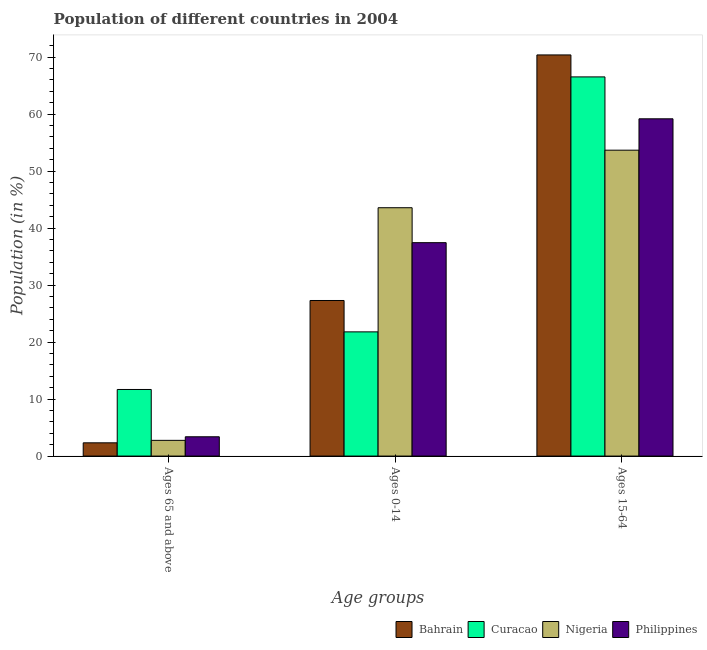How many different coloured bars are there?
Offer a very short reply. 4. How many groups of bars are there?
Provide a succinct answer. 3. How many bars are there on the 2nd tick from the left?
Offer a terse response. 4. How many bars are there on the 2nd tick from the right?
Offer a terse response. 4. What is the label of the 2nd group of bars from the left?
Offer a terse response. Ages 0-14. What is the percentage of population within the age-group 15-64 in Nigeria?
Provide a short and direct response. 53.67. Across all countries, what is the maximum percentage of population within the age-group 0-14?
Offer a very short reply. 43.57. Across all countries, what is the minimum percentage of population within the age-group of 65 and above?
Keep it short and to the point. 2.32. In which country was the percentage of population within the age-group of 65 and above maximum?
Offer a very short reply. Curacao. In which country was the percentage of population within the age-group of 65 and above minimum?
Your answer should be very brief. Bahrain. What is the total percentage of population within the age-group 0-14 in the graph?
Offer a terse response. 130.1. What is the difference between the percentage of population within the age-group 0-14 in Curacao and that in Nigeria?
Your answer should be compact. -21.78. What is the difference between the percentage of population within the age-group of 65 and above in Bahrain and the percentage of population within the age-group 15-64 in Nigeria?
Provide a short and direct response. -51.35. What is the average percentage of population within the age-group 15-64 per country?
Give a very brief answer. 62.44. What is the difference between the percentage of population within the age-group of 65 and above and percentage of population within the age-group 15-64 in Nigeria?
Your answer should be compact. -50.91. What is the ratio of the percentage of population within the age-group 15-64 in Nigeria to that in Bahrain?
Give a very brief answer. 0.76. Is the difference between the percentage of population within the age-group 0-14 in Nigeria and Philippines greater than the difference between the percentage of population within the age-group 15-64 in Nigeria and Philippines?
Keep it short and to the point. Yes. What is the difference between the highest and the second highest percentage of population within the age-group 0-14?
Ensure brevity in your answer.  6.13. What is the difference between the highest and the lowest percentage of population within the age-group 15-64?
Keep it short and to the point. 16.71. Is the sum of the percentage of population within the age-group of 65 and above in Bahrain and Philippines greater than the maximum percentage of population within the age-group 15-64 across all countries?
Keep it short and to the point. No. What does the 4th bar from the left in Ages 15-64 represents?
Keep it short and to the point. Philippines. What does the 4th bar from the right in Ages 15-64 represents?
Your response must be concise. Bahrain. How many bars are there?
Your answer should be compact. 12. How many countries are there in the graph?
Provide a succinct answer. 4. What is the difference between two consecutive major ticks on the Y-axis?
Your response must be concise. 10. What is the title of the graph?
Ensure brevity in your answer.  Population of different countries in 2004. Does "Uruguay" appear as one of the legend labels in the graph?
Your answer should be compact. No. What is the label or title of the X-axis?
Provide a succinct answer. Age groups. What is the label or title of the Y-axis?
Provide a short and direct response. Population (in %). What is the Population (in %) in Bahrain in Ages 65 and above?
Your response must be concise. 2.32. What is the Population (in %) of Curacao in Ages 65 and above?
Your response must be concise. 11.68. What is the Population (in %) of Nigeria in Ages 65 and above?
Offer a very short reply. 2.76. What is the Population (in %) in Philippines in Ages 65 and above?
Provide a short and direct response. 3.38. What is the Population (in %) of Bahrain in Ages 0-14?
Keep it short and to the point. 27.3. What is the Population (in %) in Curacao in Ages 0-14?
Give a very brief answer. 21.79. What is the Population (in %) of Nigeria in Ages 0-14?
Your response must be concise. 43.57. What is the Population (in %) of Philippines in Ages 0-14?
Offer a very short reply. 37.44. What is the Population (in %) of Bahrain in Ages 15-64?
Provide a succinct answer. 70.38. What is the Population (in %) of Curacao in Ages 15-64?
Your response must be concise. 66.53. What is the Population (in %) of Nigeria in Ages 15-64?
Give a very brief answer. 53.67. What is the Population (in %) in Philippines in Ages 15-64?
Provide a short and direct response. 59.17. Across all Age groups, what is the maximum Population (in %) in Bahrain?
Keep it short and to the point. 70.38. Across all Age groups, what is the maximum Population (in %) in Curacao?
Provide a succinct answer. 66.53. Across all Age groups, what is the maximum Population (in %) in Nigeria?
Provide a succinct answer. 53.67. Across all Age groups, what is the maximum Population (in %) of Philippines?
Give a very brief answer. 59.17. Across all Age groups, what is the minimum Population (in %) in Bahrain?
Provide a short and direct response. 2.32. Across all Age groups, what is the minimum Population (in %) of Curacao?
Keep it short and to the point. 11.68. Across all Age groups, what is the minimum Population (in %) in Nigeria?
Give a very brief answer. 2.76. Across all Age groups, what is the minimum Population (in %) of Philippines?
Your response must be concise. 3.38. What is the total Population (in %) of Nigeria in the graph?
Your answer should be compact. 100. What is the total Population (in %) in Philippines in the graph?
Provide a succinct answer. 100. What is the difference between the Population (in %) of Bahrain in Ages 65 and above and that in Ages 0-14?
Your answer should be very brief. -24.97. What is the difference between the Population (in %) of Curacao in Ages 65 and above and that in Ages 0-14?
Your answer should be very brief. -10.11. What is the difference between the Population (in %) of Nigeria in Ages 65 and above and that in Ages 0-14?
Provide a succinct answer. -40.82. What is the difference between the Population (in %) in Philippines in Ages 65 and above and that in Ages 0-14?
Your answer should be compact. -34.06. What is the difference between the Population (in %) of Bahrain in Ages 65 and above and that in Ages 15-64?
Offer a terse response. -68.06. What is the difference between the Population (in %) in Curacao in Ages 65 and above and that in Ages 15-64?
Your response must be concise. -54.84. What is the difference between the Population (in %) in Nigeria in Ages 65 and above and that in Ages 15-64?
Provide a succinct answer. -50.91. What is the difference between the Population (in %) of Philippines in Ages 65 and above and that in Ages 15-64?
Your answer should be compact. -55.79. What is the difference between the Population (in %) in Bahrain in Ages 0-14 and that in Ages 15-64?
Keep it short and to the point. -43.08. What is the difference between the Population (in %) in Curacao in Ages 0-14 and that in Ages 15-64?
Provide a short and direct response. -44.73. What is the difference between the Population (in %) of Nigeria in Ages 0-14 and that in Ages 15-64?
Your answer should be compact. -10.1. What is the difference between the Population (in %) of Philippines in Ages 0-14 and that in Ages 15-64?
Ensure brevity in your answer.  -21.73. What is the difference between the Population (in %) in Bahrain in Ages 65 and above and the Population (in %) in Curacao in Ages 0-14?
Offer a very short reply. -19.47. What is the difference between the Population (in %) in Bahrain in Ages 65 and above and the Population (in %) in Nigeria in Ages 0-14?
Your response must be concise. -41.25. What is the difference between the Population (in %) in Bahrain in Ages 65 and above and the Population (in %) in Philippines in Ages 0-14?
Keep it short and to the point. -35.12. What is the difference between the Population (in %) in Curacao in Ages 65 and above and the Population (in %) in Nigeria in Ages 0-14?
Make the answer very short. -31.89. What is the difference between the Population (in %) of Curacao in Ages 65 and above and the Population (in %) of Philippines in Ages 0-14?
Provide a succinct answer. -25.76. What is the difference between the Population (in %) in Nigeria in Ages 65 and above and the Population (in %) in Philippines in Ages 0-14?
Ensure brevity in your answer.  -34.68. What is the difference between the Population (in %) in Bahrain in Ages 65 and above and the Population (in %) in Curacao in Ages 15-64?
Offer a very short reply. -64.2. What is the difference between the Population (in %) of Bahrain in Ages 65 and above and the Population (in %) of Nigeria in Ages 15-64?
Your response must be concise. -51.35. What is the difference between the Population (in %) in Bahrain in Ages 65 and above and the Population (in %) in Philippines in Ages 15-64?
Your response must be concise. -56.85. What is the difference between the Population (in %) in Curacao in Ages 65 and above and the Population (in %) in Nigeria in Ages 15-64?
Provide a short and direct response. -41.99. What is the difference between the Population (in %) of Curacao in Ages 65 and above and the Population (in %) of Philippines in Ages 15-64?
Give a very brief answer. -47.49. What is the difference between the Population (in %) in Nigeria in Ages 65 and above and the Population (in %) in Philippines in Ages 15-64?
Make the answer very short. -56.42. What is the difference between the Population (in %) in Bahrain in Ages 0-14 and the Population (in %) in Curacao in Ages 15-64?
Provide a short and direct response. -39.23. What is the difference between the Population (in %) in Bahrain in Ages 0-14 and the Population (in %) in Nigeria in Ages 15-64?
Provide a succinct answer. -26.37. What is the difference between the Population (in %) in Bahrain in Ages 0-14 and the Population (in %) in Philippines in Ages 15-64?
Provide a short and direct response. -31.88. What is the difference between the Population (in %) of Curacao in Ages 0-14 and the Population (in %) of Nigeria in Ages 15-64?
Offer a terse response. -31.88. What is the difference between the Population (in %) in Curacao in Ages 0-14 and the Population (in %) in Philippines in Ages 15-64?
Keep it short and to the point. -37.38. What is the difference between the Population (in %) in Nigeria in Ages 0-14 and the Population (in %) in Philippines in Ages 15-64?
Give a very brief answer. -15.6. What is the average Population (in %) of Bahrain per Age groups?
Your response must be concise. 33.33. What is the average Population (in %) in Curacao per Age groups?
Keep it short and to the point. 33.33. What is the average Population (in %) of Nigeria per Age groups?
Make the answer very short. 33.33. What is the average Population (in %) of Philippines per Age groups?
Your answer should be very brief. 33.33. What is the difference between the Population (in %) in Bahrain and Population (in %) in Curacao in Ages 65 and above?
Your answer should be very brief. -9.36. What is the difference between the Population (in %) of Bahrain and Population (in %) of Nigeria in Ages 65 and above?
Offer a terse response. -0.43. What is the difference between the Population (in %) of Bahrain and Population (in %) of Philippines in Ages 65 and above?
Offer a terse response. -1.06. What is the difference between the Population (in %) of Curacao and Population (in %) of Nigeria in Ages 65 and above?
Make the answer very short. 8.93. What is the difference between the Population (in %) in Curacao and Population (in %) in Philippines in Ages 65 and above?
Your answer should be very brief. 8.3. What is the difference between the Population (in %) in Nigeria and Population (in %) in Philippines in Ages 65 and above?
Provide a short and direct response. -0.63. What is the difference between the Population (in %) in Bahrain and Population (in %) in Curacao in Ages 0-14?
Your response must be concise. 5.5. What is the difference between the Population (in %) of Bahrain and Population (in %) of Nigeria in Ages 0-14?
Offer a terse response. -16.28. What is the difference between the Population (in %) in Bahrain and Population (in %) in Philippines in Ages 0-14?
Make the answer very short. -10.15. What is the difference between the Population (in %) of Curacao and Population (in %) of Nigeria in Ages 0-14?
Offer a very short reply. -21.78. What is the difference between the Population (in %) in Curacao and Population (in %) in Philippines in Ages 0-14?
Provide a succinct answer. -15.65. What is the difference between the Population (in %) of Nigeria and Population (in %) of Philippines in Ages 0-14?
Provide a short and direct response. 6.13. What is the difference between the Population (in %) in Bahrain and Population (in %) in Curacao in Ages 15-64?
Ensure brevity in your answer.  3.86. What is the difference between the Population (in %) of Bahrain and Population (in %) of Nigeria in Ages 15-64?
Ensure brevity in your answer.  16.71. What is the difference between the Population (in %) of Bahrain and Population (in %) of Philippines in Ages 15-64?
Make the answer very short. 11.21. What is the difference between the Population (in %) in Curacao and Population (in %) in Nigeria in Ages 15-64?
Keep it short and to the point. 12.86. What is the difference between the Population (in %) in Curacao and Population (in %) in Philippines in Ages 15-64?
Ensure brevity in your answer.  7.35. What is the difference between the Population (in %) in Nigeria and Population (in %) in Philippines in Ages 15-64?
Provide a succinct answer. -5.51. What is the ratio of the Population (in %) in Bahrain in Ages 65 and above to that in Ages 0-14?
Provide a succinct answer. 0.09. What is the ratio of the Population (in %) of Curacao in Ages 65 and above to that in Ages 0-14?
Make the answer very short. 0.54. What is the ratio of the Population (in %) of Nigeria in Ages 65 and above to that in Ages 0-14?
Your answer should be compact. 0.06. What is the ratio of the Population (in %) in Philippines in Ages 65 and above to that in Ages 0-14?
Your answer should be compact. 0.09. What is the ratio of the Population (in %) of Bahrain in Ages 65 and above to that in Ages 15-64?
Your response must be concise. 0.03. What is the ratio of the Population (in %) of Curacao in Ages 65 and above to that in Ages 15-64?
Keep it short and to the point. 0.18. What is the ratio of the Population (in %) of Nigeria in Ages 65 and above to that in Ages 15-64?
Your answer should be very brief. 0.05. What is the ratio of the Population (in %) of Philippines in Ages 65 and above to that in Ages 15-64?
Provide a short and direct response. 0.06. What is the ratio of the Population (in %) of Bahrain in Ages 0-14 to that in Ages 15-64?
Offer a very short reply. 0.39. What is the ratio of the Population (in %) of Curacao in Ages 0-14 to that in Ages 15-64?
Give a very brief answer. 0.33. What is the ratio of the Population (in %) in Nigeria in Ages 0-14 to that in Ages 15-64?
Your response must be concise. 0.81. What is the ratio of the Population (in %) of Philippines in Ages 0-14 to that in Ages 15-64?
Provide a short and direct response. 0.63. What is the difference between the highest and the second highest Population (in %) in Bahrain?
Offer a very short reply. 43.08. What is the difference between the highest and the second highest Population (in %) of Curacao?
Your answer should be very brief. 44.73. What is the difference between the highest and the second highest Population (in %) in Nigeria?
Keep it short and to the point. 10.1. What is the difference between the highest and the second highest Population (in %) in Philippines?
Offer a terse response. 21.73. What is the difference between the highest and the lowest Population (in %) of Bahrain?
Keep it short and to the point. 68.06. What is the difference between the highest and the lowest Population (in %) of Curacao?
Your answer should be compact. 54.84. What is the difference between the highest and the lowest Population (in %) of Nigeria?
Provide a short and direct response. 50.91. What is the difference between the highest and the lowest Population (in %) in Philippines?
Offer a terse response. 55.79. 